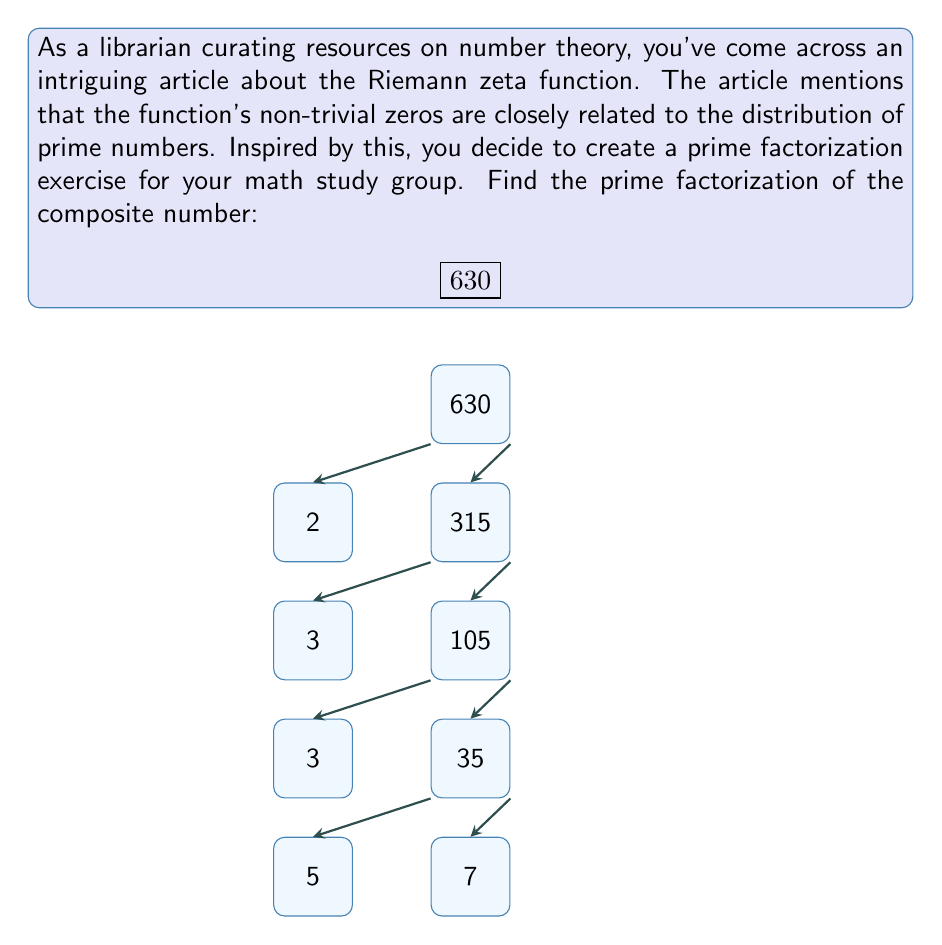Provide a solution to this math problem. To find the prime factorization of 630, we'll use the following steps:

1) Start dividing 630 by the smallest prime number that divides it evenly.

2) Continue this process with the quotient until the quotient itself is a prime number.

Step 1: 630 ÷ 2 = 315
$630 = 2 \times 315$

Step 2: 315 ÷ 3 = 105
$630 = 2 \times 3 \times 105$

Step 3: 105 ÷ 3 = 35
$630 = 2 \times 3 \times 3 \times 35$

Step 4: 35 ÷ 5 = 7
$630 = 2 \times 3 \times 3 \times 5 \times 7$

At this point, we're left with 7, which is itself a prime number, so we stop.

Therefore, the prime factorization of 630 is:

$$630 = 2 \times 3^2 \times 5 \times 7$$

We can verify this by multiplying these factors:
$2 \times 3 \times 3 \times 5 \times 7 = 2 \times 9 \times 5 \times 7 = 18 \times 35 = 630$
Answer: $2 \times 3^2 \times 5 \times 7$ 